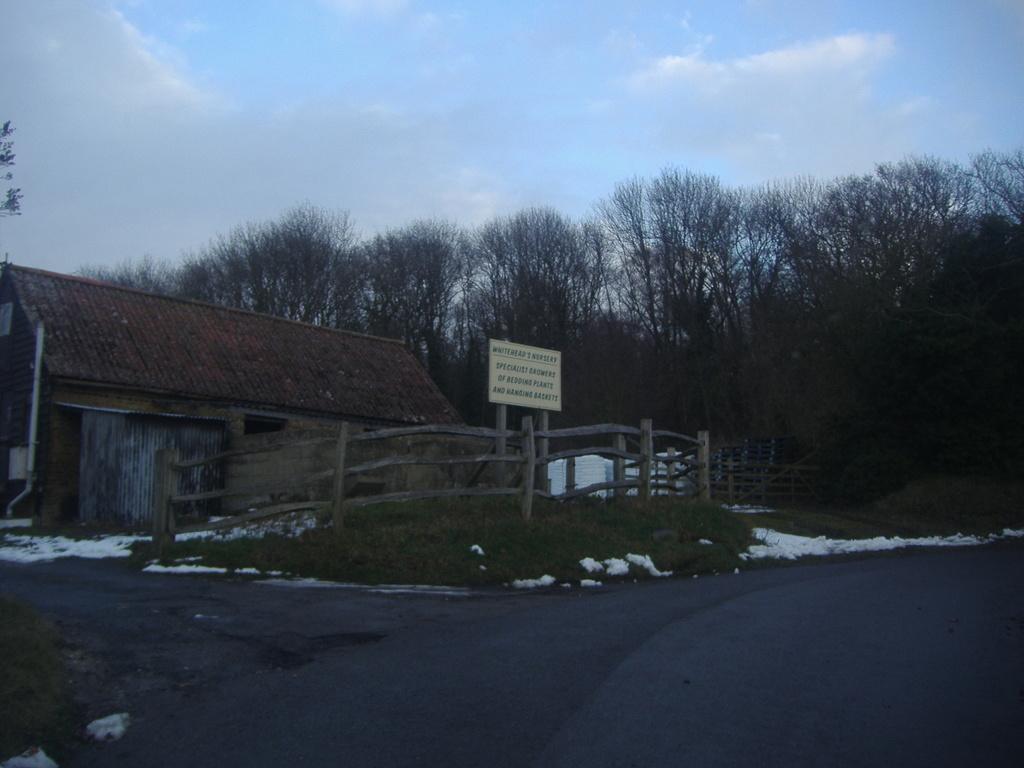Could you give a brief overview of what you see in this image? This image consists of a road. In the front, there is a fencing made up of wood. To the left, there is a house. In the background, there are many trees. At the top, there are clouds in the sky. 